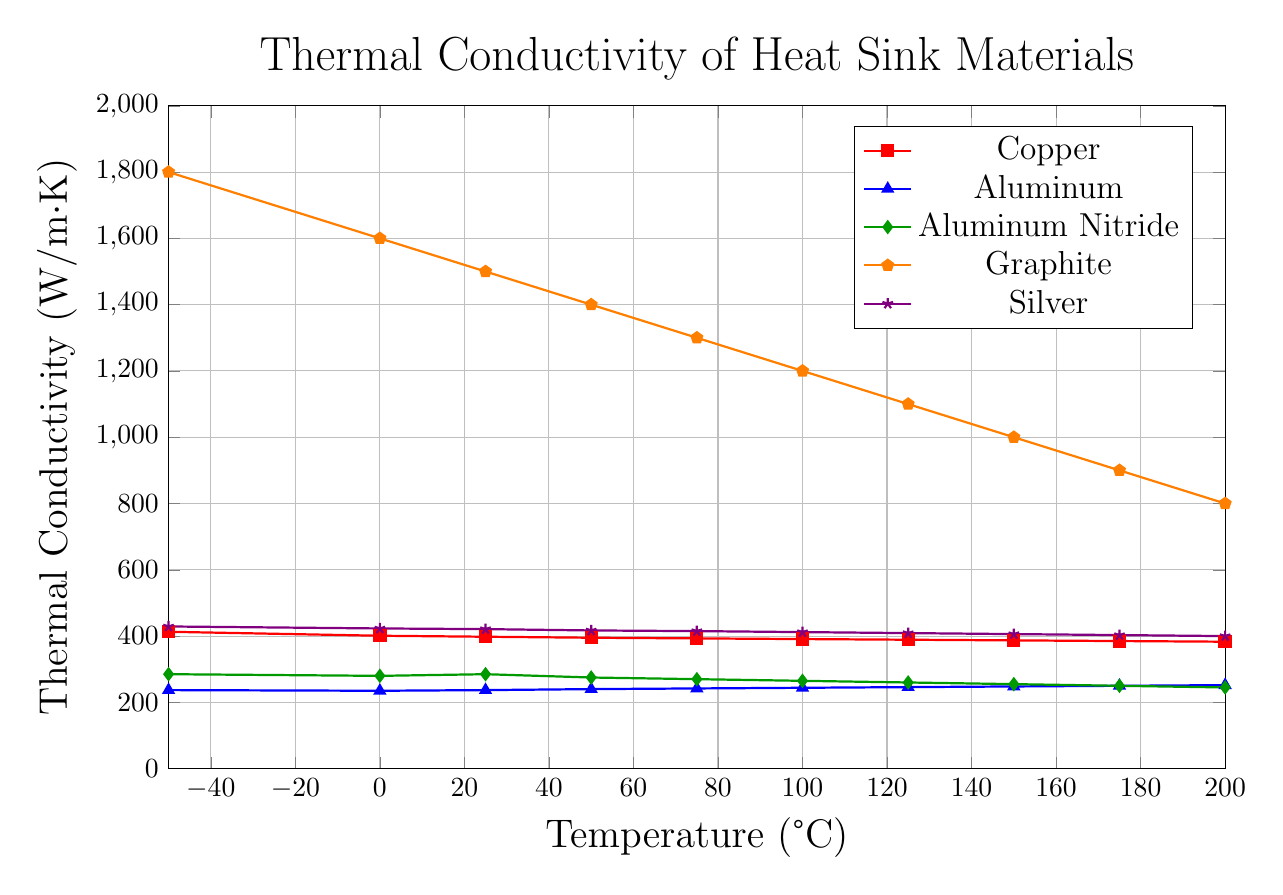Which material has the highest thermal conductivity at -50°C? By examining the plot, we see that the material with the highest thermal conductivity at -50°C is indicated by a red-colored line with the highest peak. This is Graphite.
Answer: Graphite Which material's thermal conductivity increases with temperature? By analyzing the trend of all the lines, we observe that the blue-colored line, corresponding to Aluminum, shows an increase in thermal conductivity as the temperature rises.
Answer: Aluminum What is the thermal conductivity of Silver at 100°C? To find the thermal conductivity of Silver at 100°C, we look for the violet-colored line and its value at 100°C, which is 412 W/m·K.
Answer: 412 W/m·K Compare the thermal conductivity of Copper and Aluminum at 0°C. Which one is higher? Copper (red) and Aluminum (blue) lines intersect at 0°C. As indicated, Copper's value is 401 W/m·K, and Aluminum's is 235 W/m·K. Copper's thermal conductivity is higher.
Answer: Copper At what temperature is the thermal conductivity of Aluminum Nitride equal to 260 W/m·K? We examine the green line for Aluminum Nitride and find when its value is 260 W/m·K, which corresponds to the temperature of 125°C.
Answer: 125°C How does the thermal conductivity of Graphite change from -50°C to 200°C? We observe the orange line representing Graphite, noting it starts at 1800 W/m·K at -50°C and falls continuously to 800 W/m·K at 200°C.
Answer: Decreases significantly What is the average thermal conductivity of Copper across all temperatures? The values for Copper are 413, 401, 398, 395, 393, 391, 389, 387, 385, 383 W/m·K. Summing them gives 3935, and dividing by 10 (number of points) gives an average of 393.5.
Answer: 393.5 W/m·K Is there any material with a nearly constant thermal conductivity across the temperature range? By observing all the lines, the smallest change occurs for the Silver (violet), ranging from 429 to 400 W/m·K, indicating a nearly constant conductivity.
Answer: Silver Which two materials' thermal conductivities are closest to each other at 50°C? At 50°C, the thermal conductivities are: Copper 395, Aluminum 240, Aluminum Nitride 275, Graphite 1400, Silver 417 W/m·K. The closest values are Aluminum and Aluminum Nitride, differing by only 35 W/m·K.
Answer: Aluminum and Aluminum Nitride 